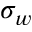<formula> <loc_0><loc_0><loc_500><loc_500>\sigma _ { w }</formula> 